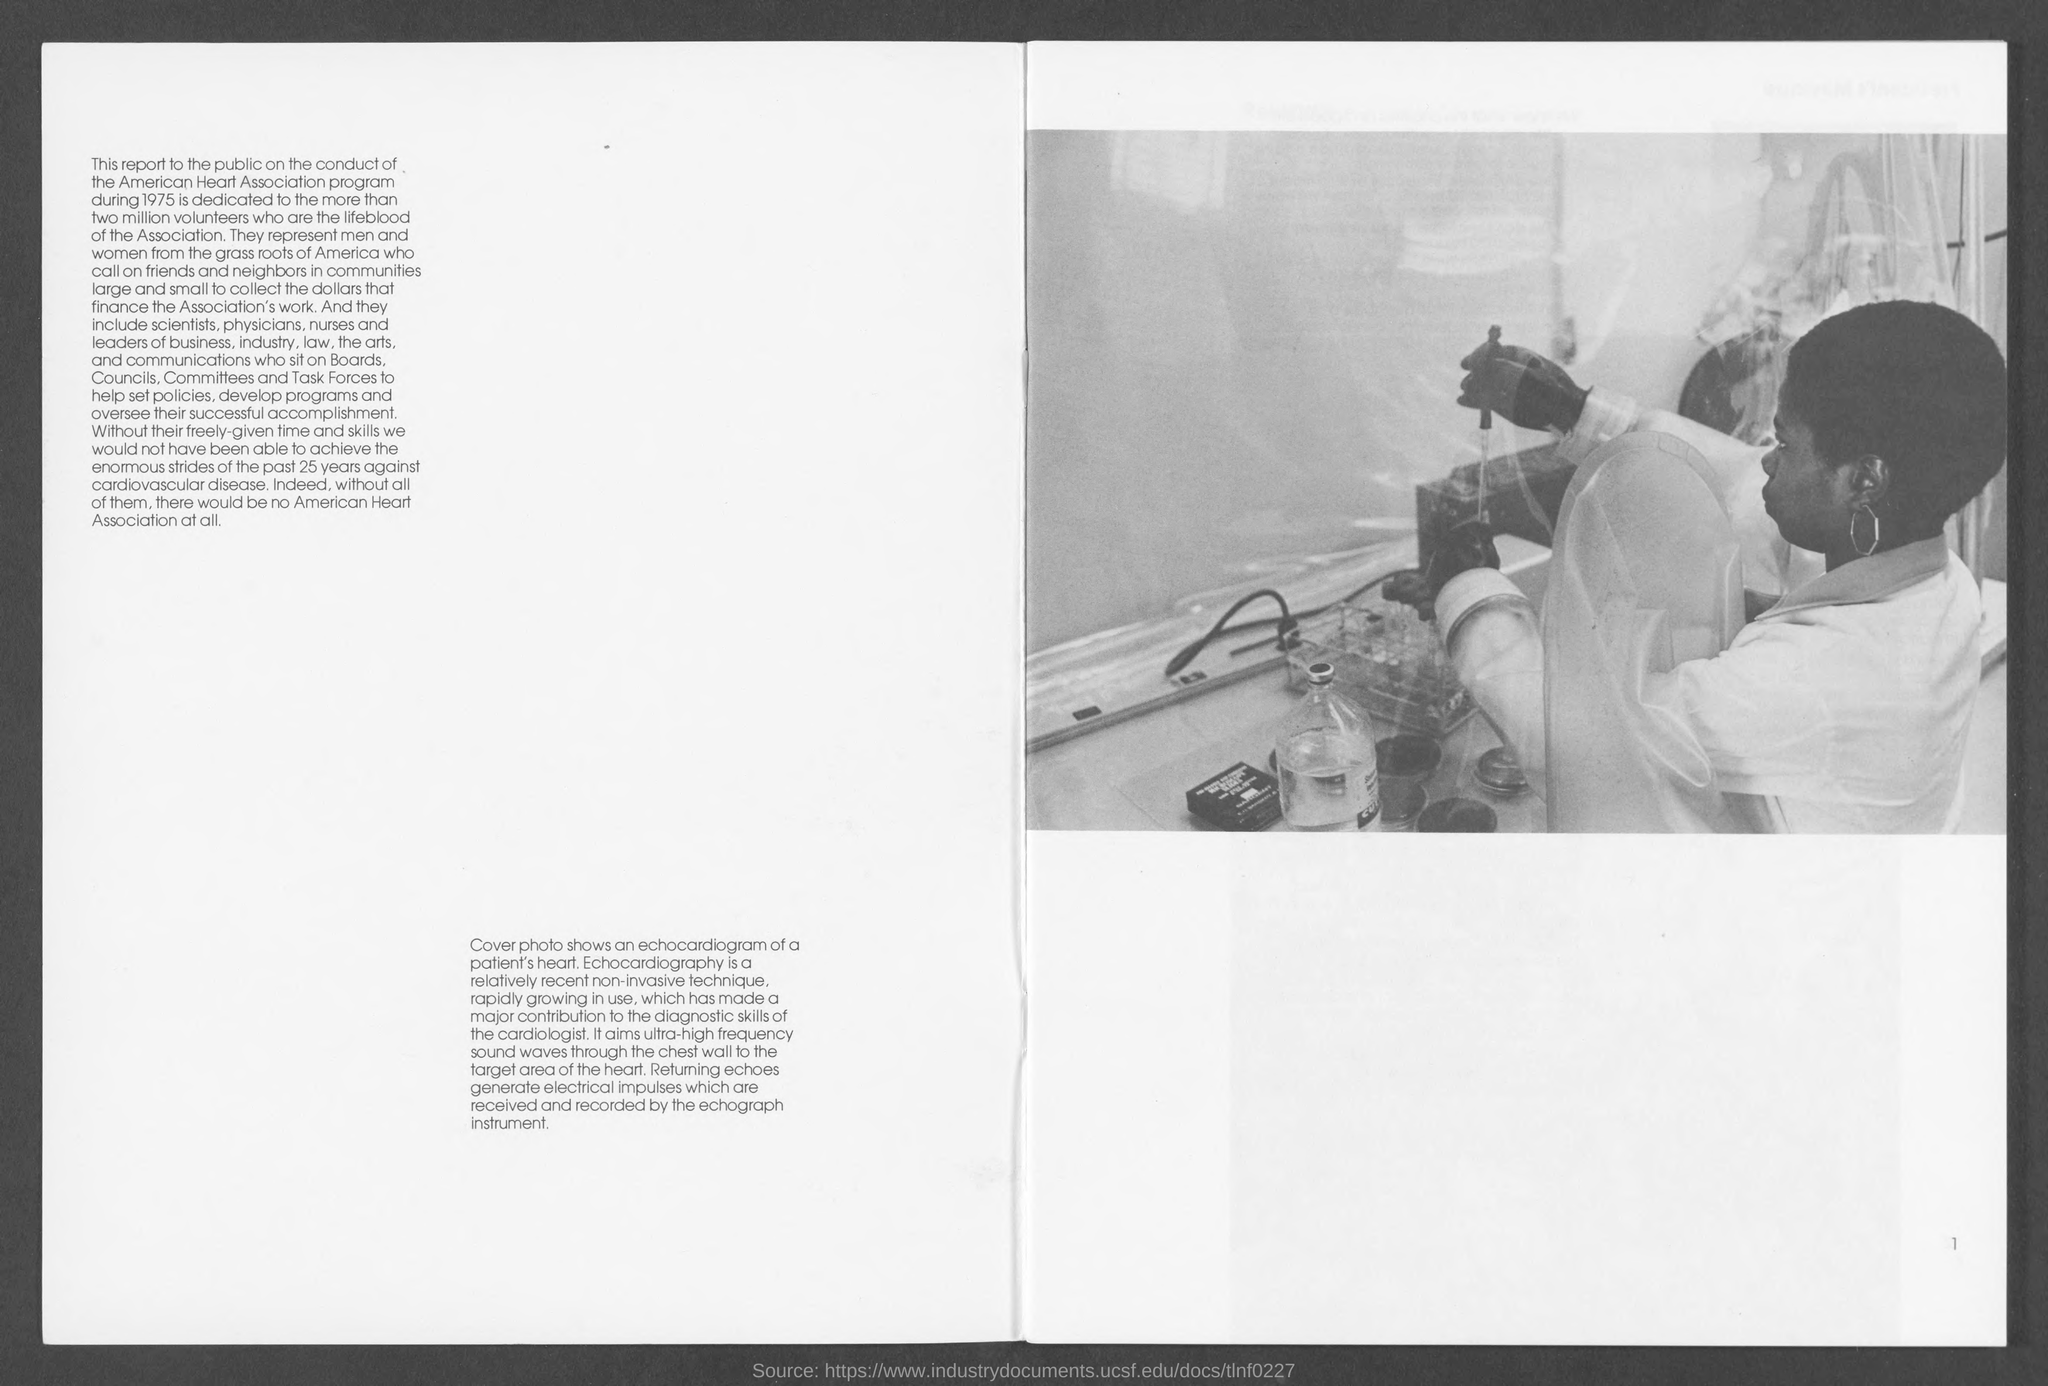What is the number at bottom- right corner of the page ?
Offer a very short reply. 1. 